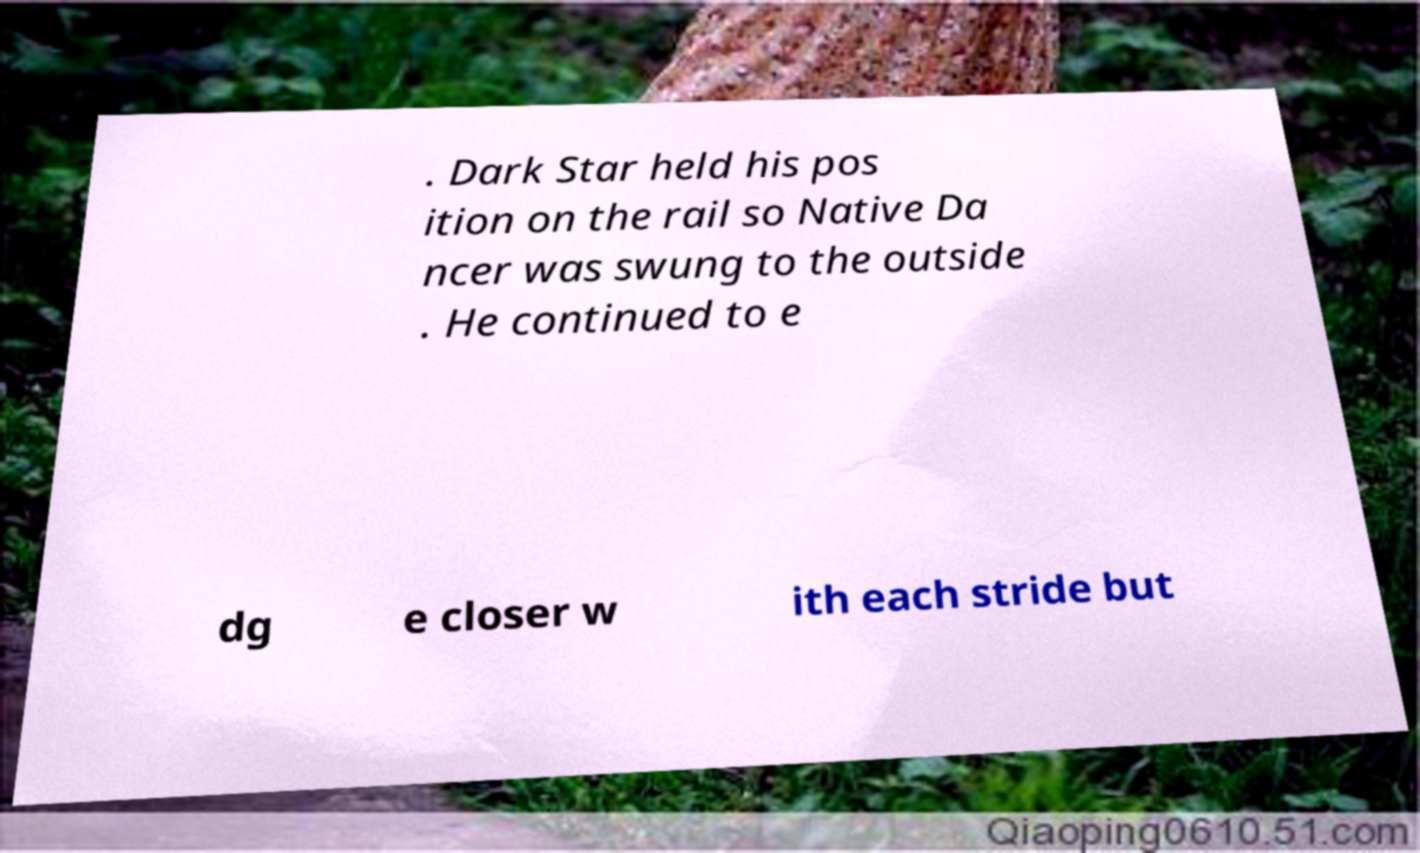There's text embedded in this image that I need extracted. Can you transcribe it verbatim? . Dark Star held his pos ition on the rail so Native Da ncer was swung to the outside . He continued to e dg e closer w ith each stride but 